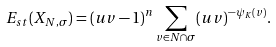Convert formula to latex. <formula><loc_0><loc_0><loc_500><loc_500>E _ { s t } ( X _ { N , \sigma } ) = ( u v - 1 ) ^ { n } \sum _ { v \in N \cap \sigma } ( u v ) ^ { - \psi _ { K } ( v ) } .</formula> 